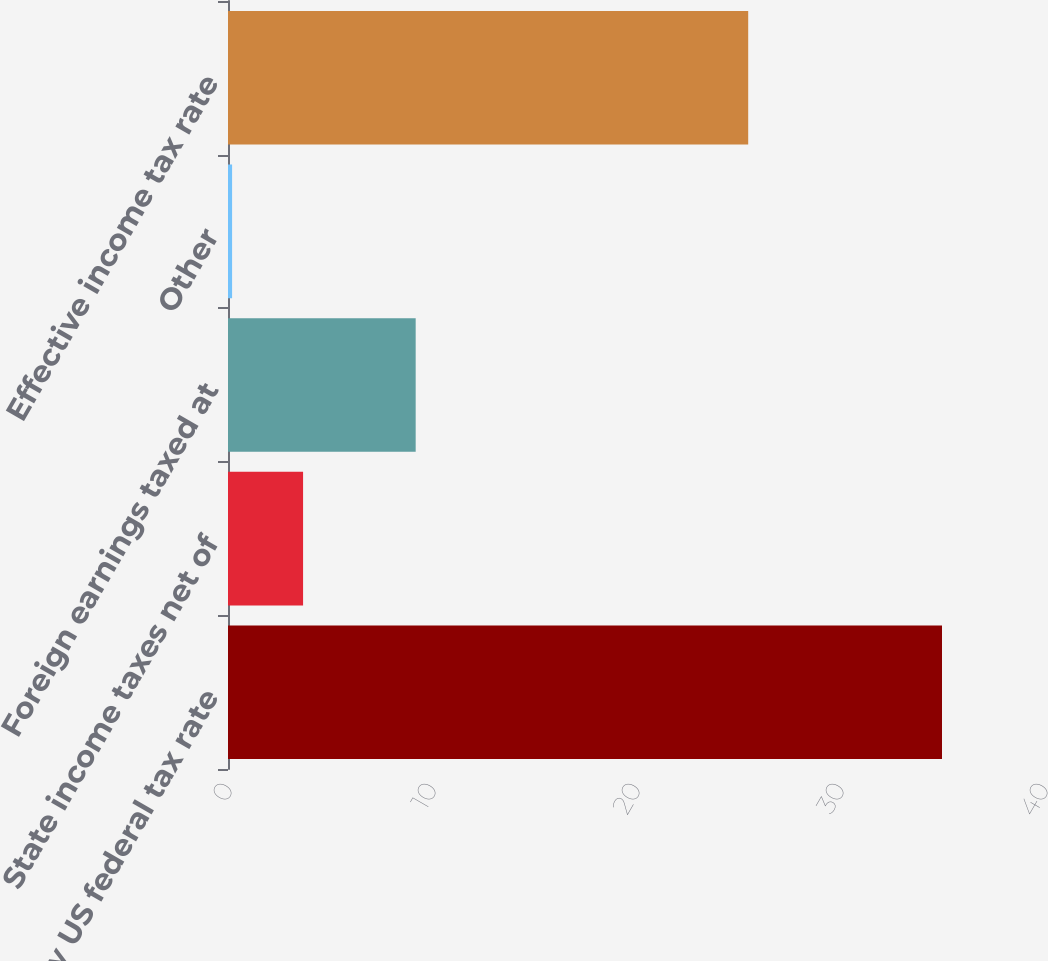Convert chart to OTSL. <chart><loc_0><loc_0><loc_500><loc_500><bar_chart><fcel>Statutory US federal tax rate<fcel>State income taxes net of<fcel>Foreign earnings taxed at<fcel>Other<fcel>Effective income tax rate<nl><fcel>35<fcel>3.68<fcel>9.2<fcel>0.2<fcel>25.5<nl></chart> 